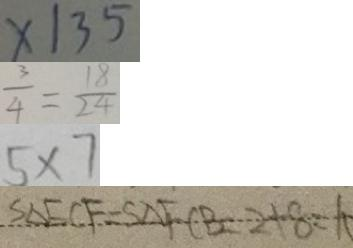<formula> <loc_0><loc_0><loc_500><loc_500>x \vert 3 5 
 \frac { 3 } { 4 } = \frac { 1 8 } { 2 4 } 
 5 \times 7 
 S _ { \Delta } E C F = S _ { \Delta } F C B 2 + 8 = 1 0</formula> 